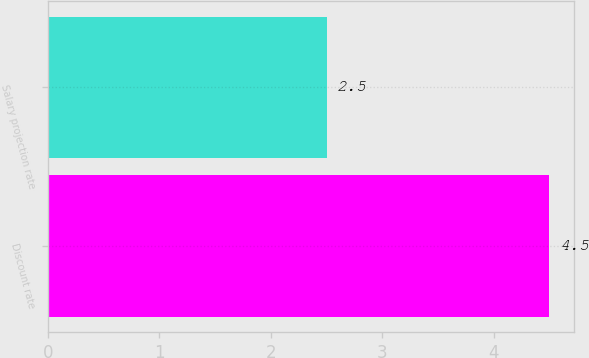<chart> <loc_0><loc_0><loc_500><loc_500><bar_chart><fcel>Discount rate<fcel>Salary projection rate<nl><fcel>4.5<fcel>2.5<nl></chart> 